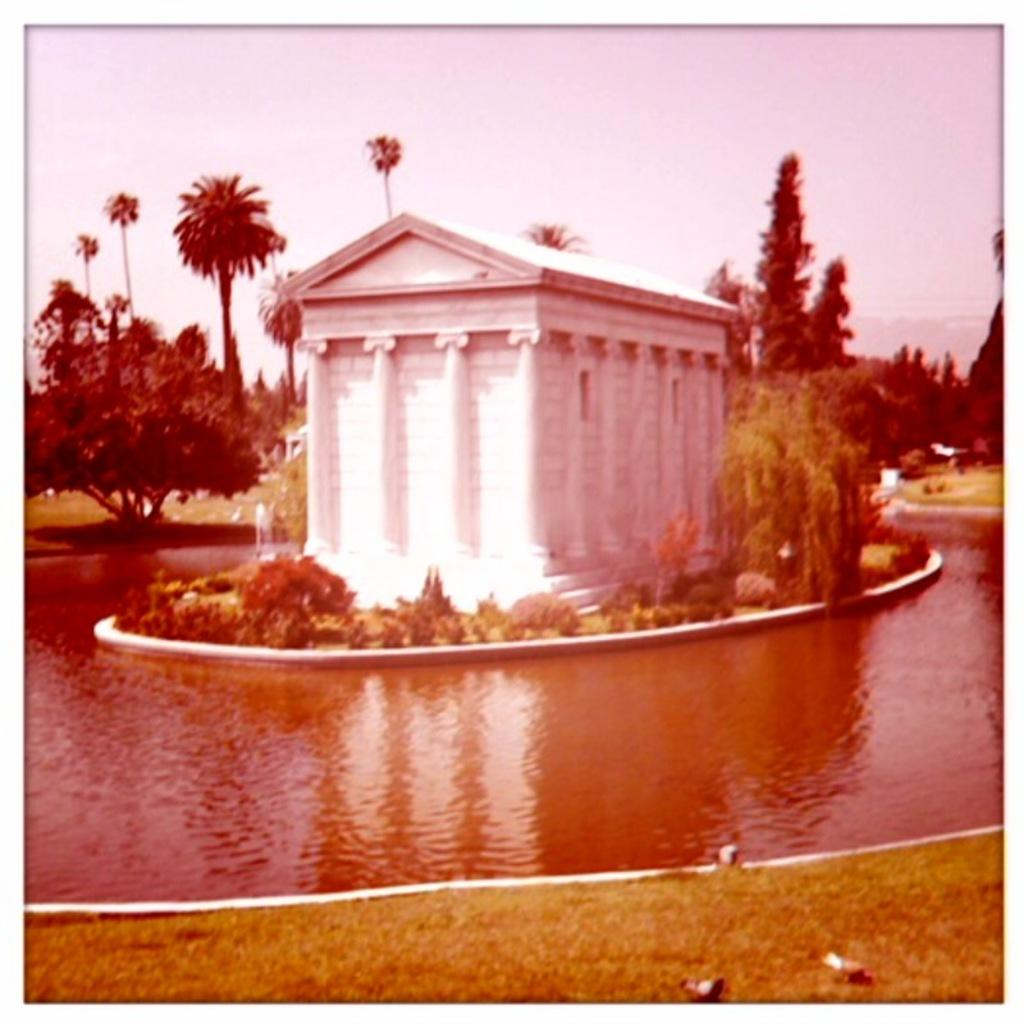What type of body of water is present in the image? There is a pond in the image. What structure is located in the middle of the image? There is a house in the middle of the image. What type of vegetation can be seen in the background of the image? There are trees in the background of the image. What is visible above the house and trees in the image? The sky is visible in the image. What is the name of the kitten playing with a bone near the pond in the image? There is no kitten or bone present in the image. What type of bone can be seen near the house in the image? There is no bone present in the image. 